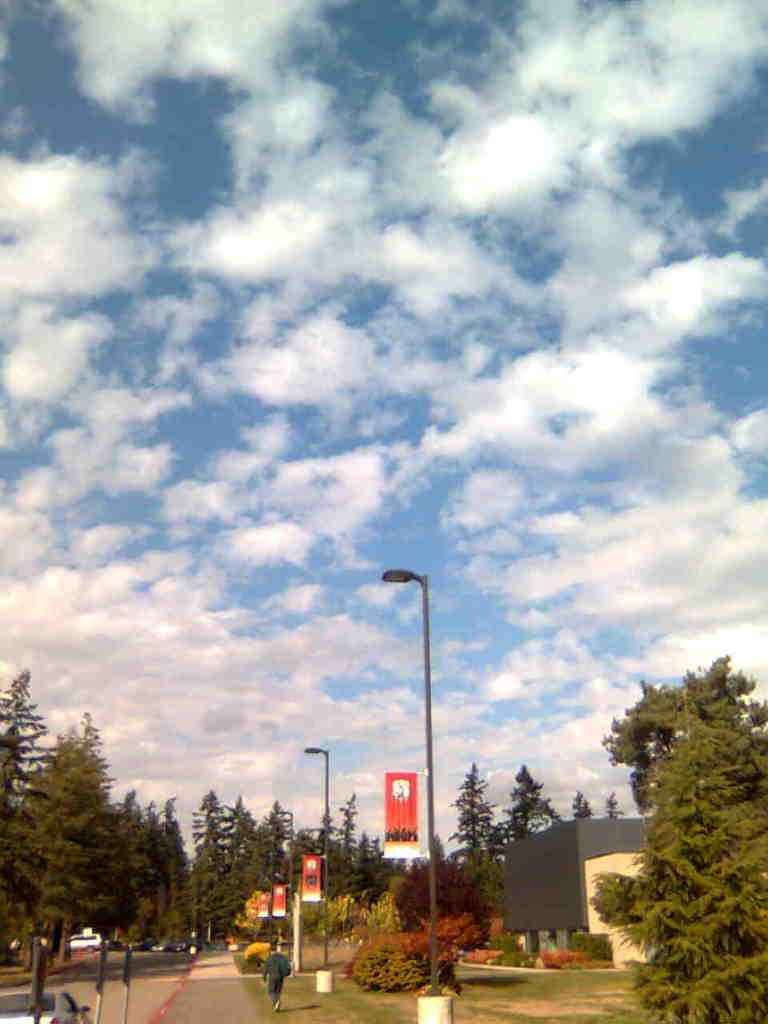Please provide a concise description of this image. There is one person standing at the bottom of this image and there are some trees in the background. There is a building on the right side of this image. There is a cloudy sky at the top of this image. 